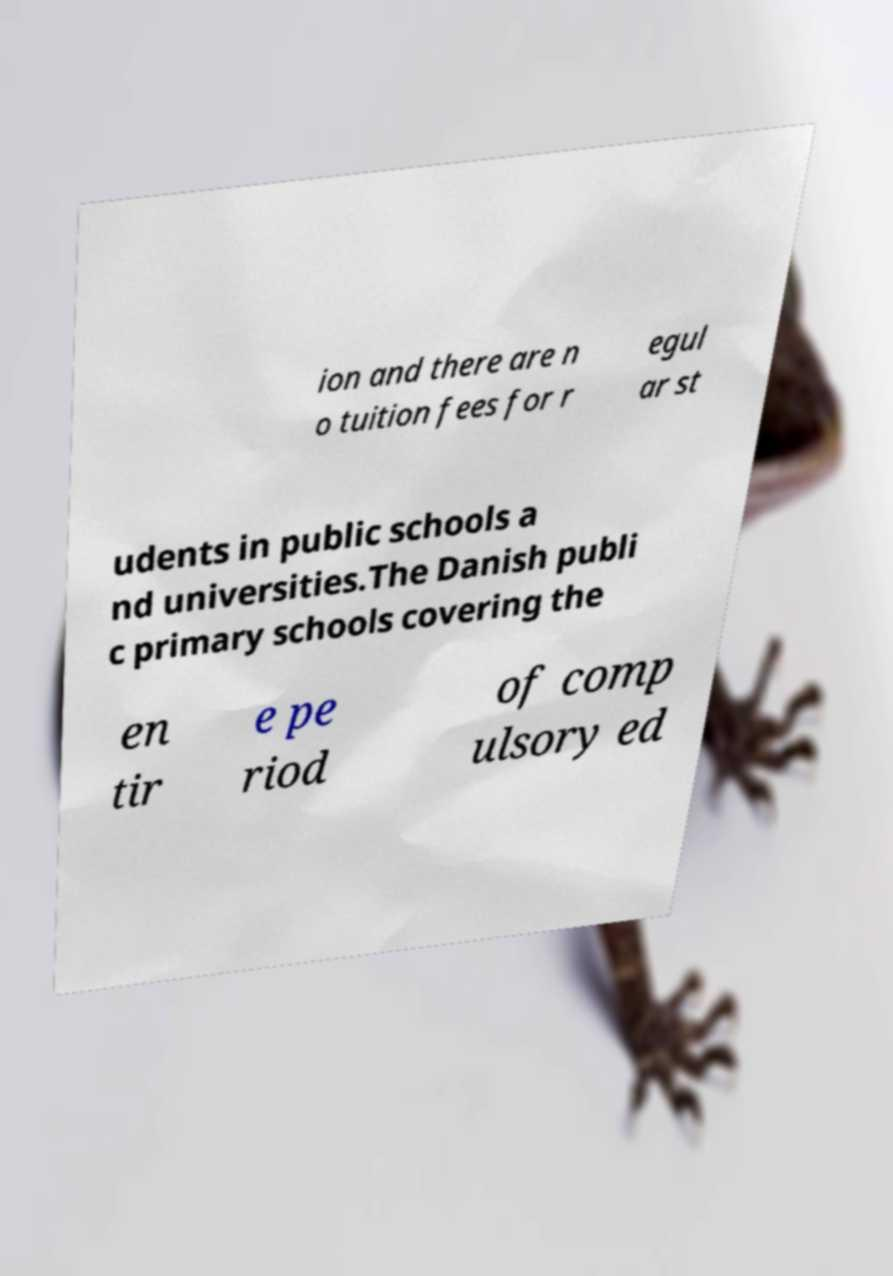What messages or text are displayed in this image? I need them in a readable, typed format. ion and there are n o tuition fees for r egul ar st udents in public schools a nd universities.The Danish publi c primary schools covering the en tir e pe riod of comp ulsory ed 